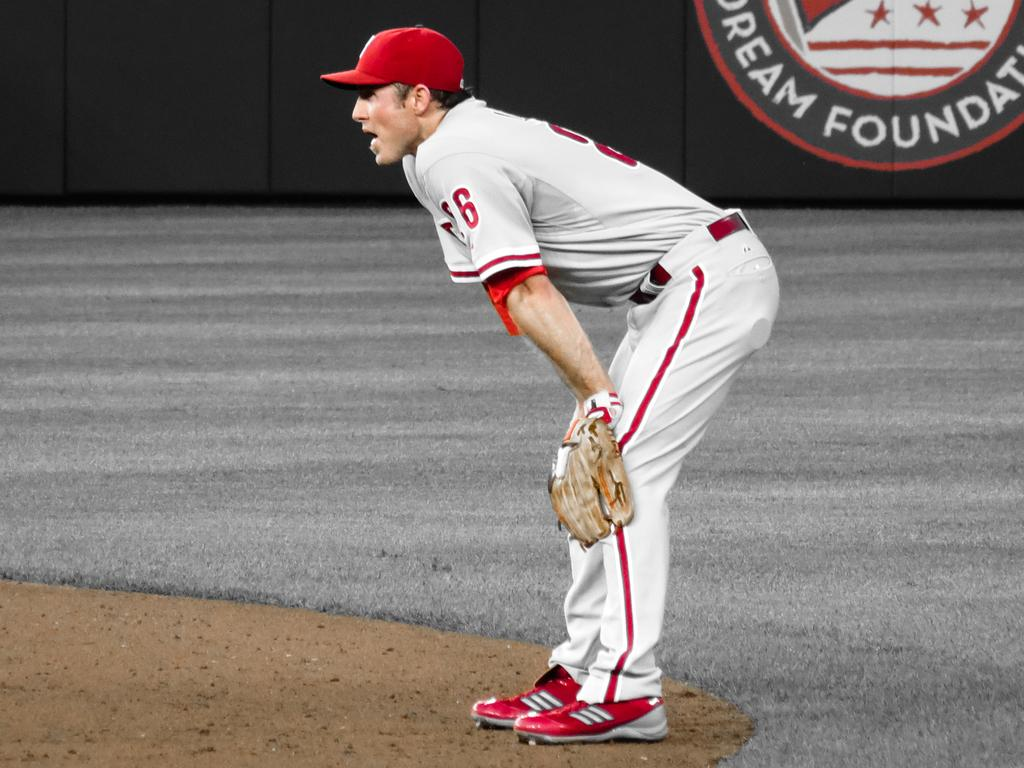<image>
Provide a brief description of the given image. A baseball player is standing in the outfield by a sign that says Dream Foundation. 